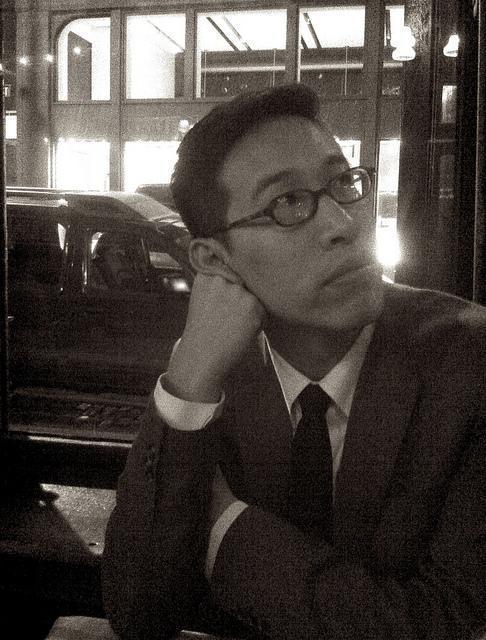How many cars are visible?
Give a very brief answer. 1. How many people can be seen?
Give a very brief answer. 2. 